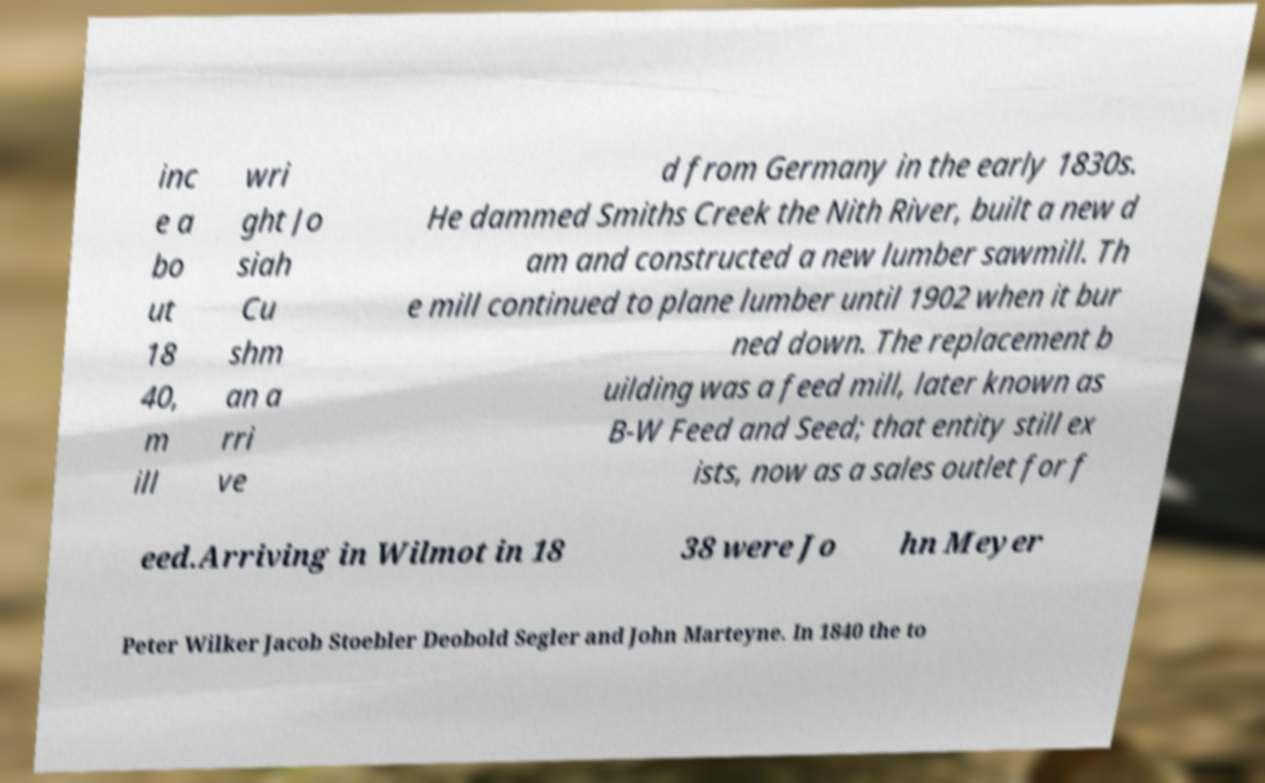Please read and relay the text visible in this image. What does it say? inc e a bo ut 18 40, m ill wri ght Jo siah Cu shm an a rri ve d from Germany in the early 1830s. He dammed Smiths Creek the Nith River, built a new d am and constructed a new lumber sawmill. Th e mill continued to plane lumber until 1902 when it bur ned down. The replacement b uilding was a feed mill, later known as B-W Feed and Seed; that entity still ex ists, now as a sales outlet for f eed.Arriving in Wilmot in 18 38 were Jo hn Meyer Peter Wilker Jacob Stoebler Deobold Segler and John Marteyne. In 1840 the to 